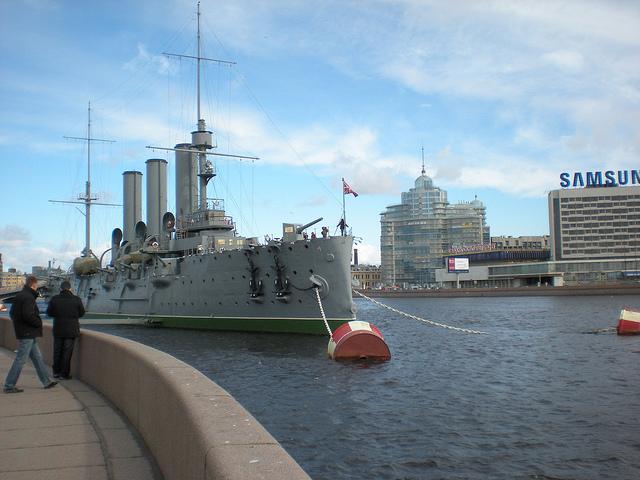How many people are there?
Concise answer only. 2. What is waving on the front of the boat?
Answer briefly. Flag. How many people are seen?
Short answer required. 2. What is the largest object in the water?
Answer briefly. Ship. 